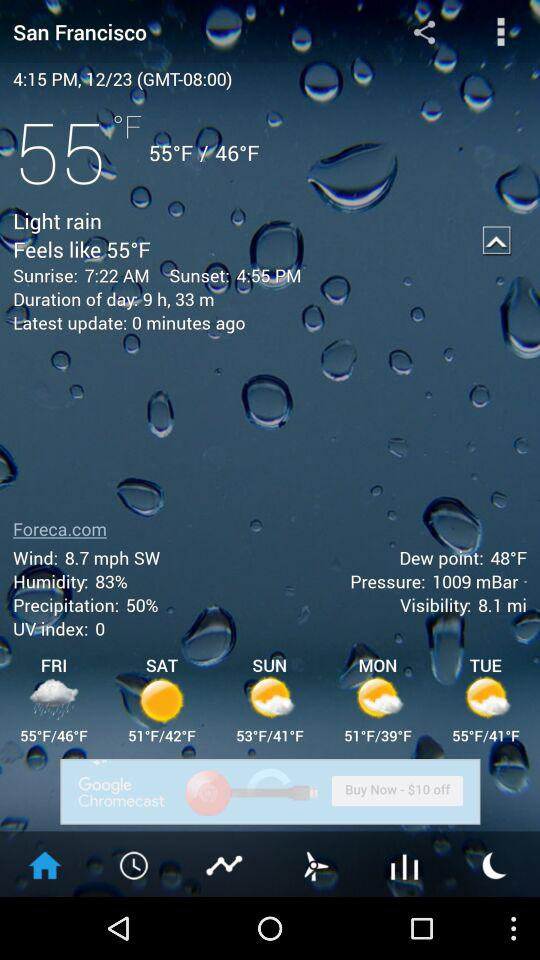What is the humidity in San Francisco?
Answer the question using a single word or phrase. 83% 